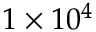<formula> <loc_0><loc_0><loc_500><loc_500>1 \times 1 0 ^ { 4 }</formula> 